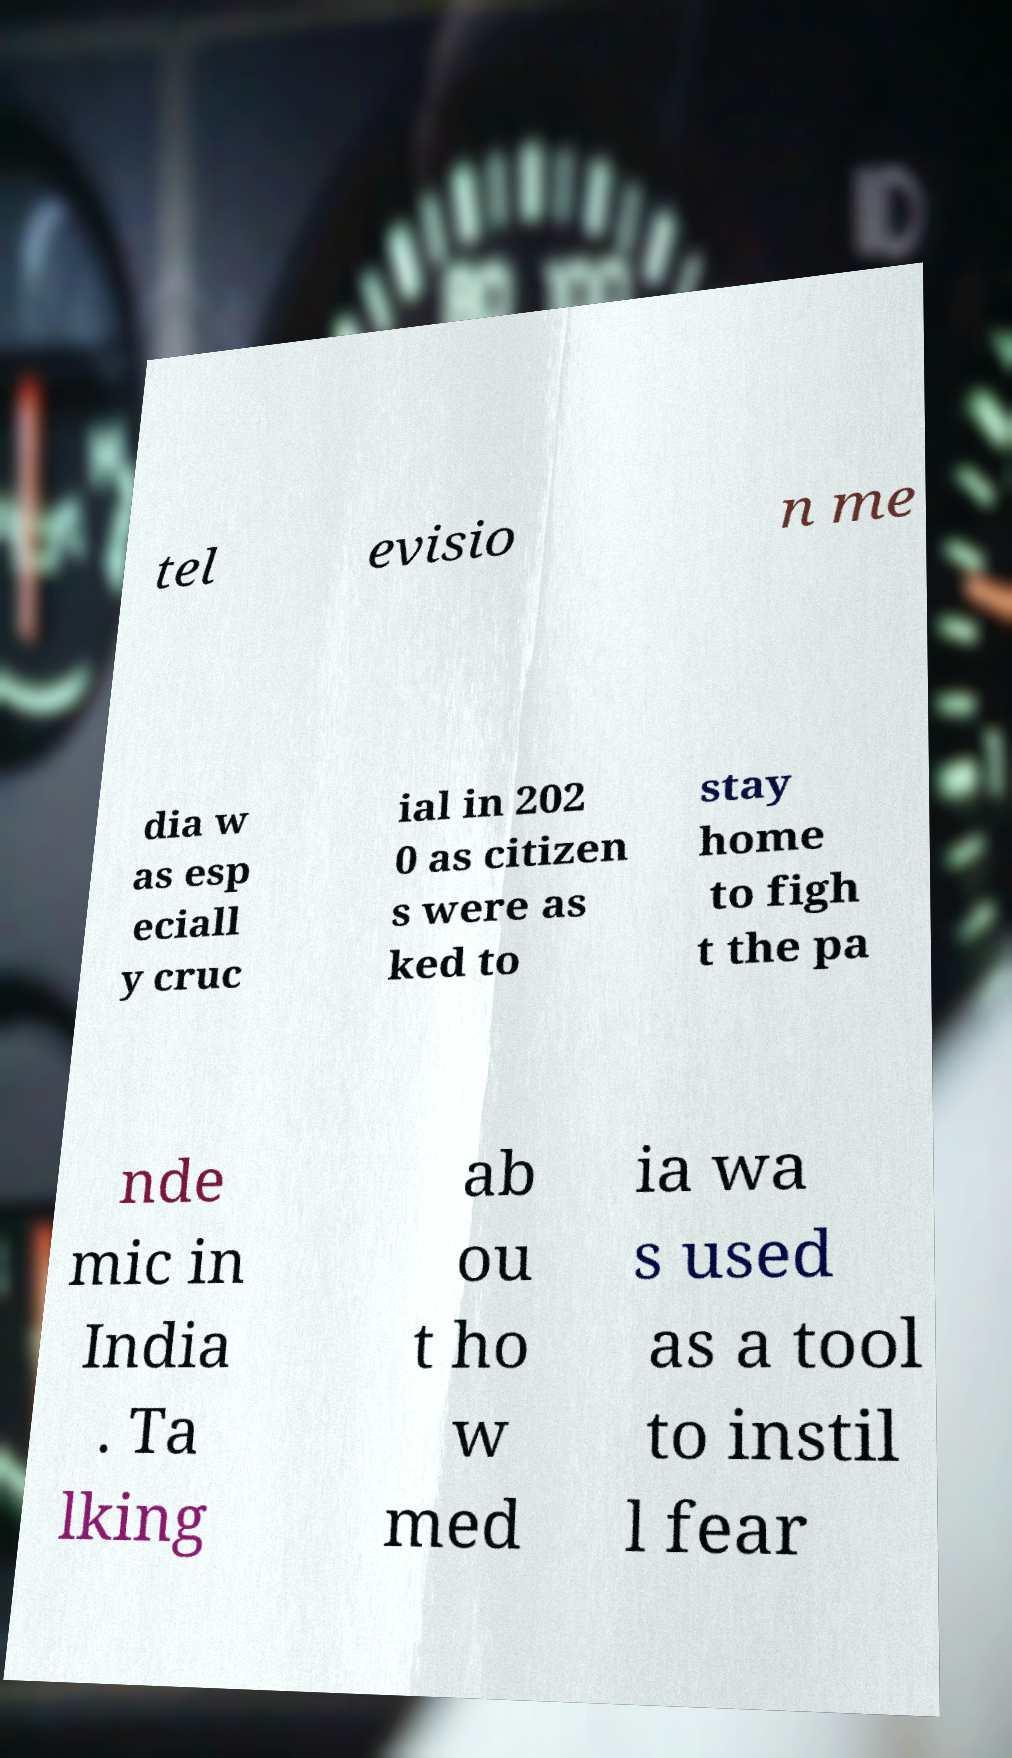Can you read and provide the text displayed in the image?This photo seems to have some interesting text. Can you extract and type it out for me? tel evisio n me dia w as esp eciall y cruc ial in 202 0 as citizen s were as ked to stay home to figh t the pa nde mic in India . Ta lking ab ou t ho w med ia wa s used as a tool to instil l fear 